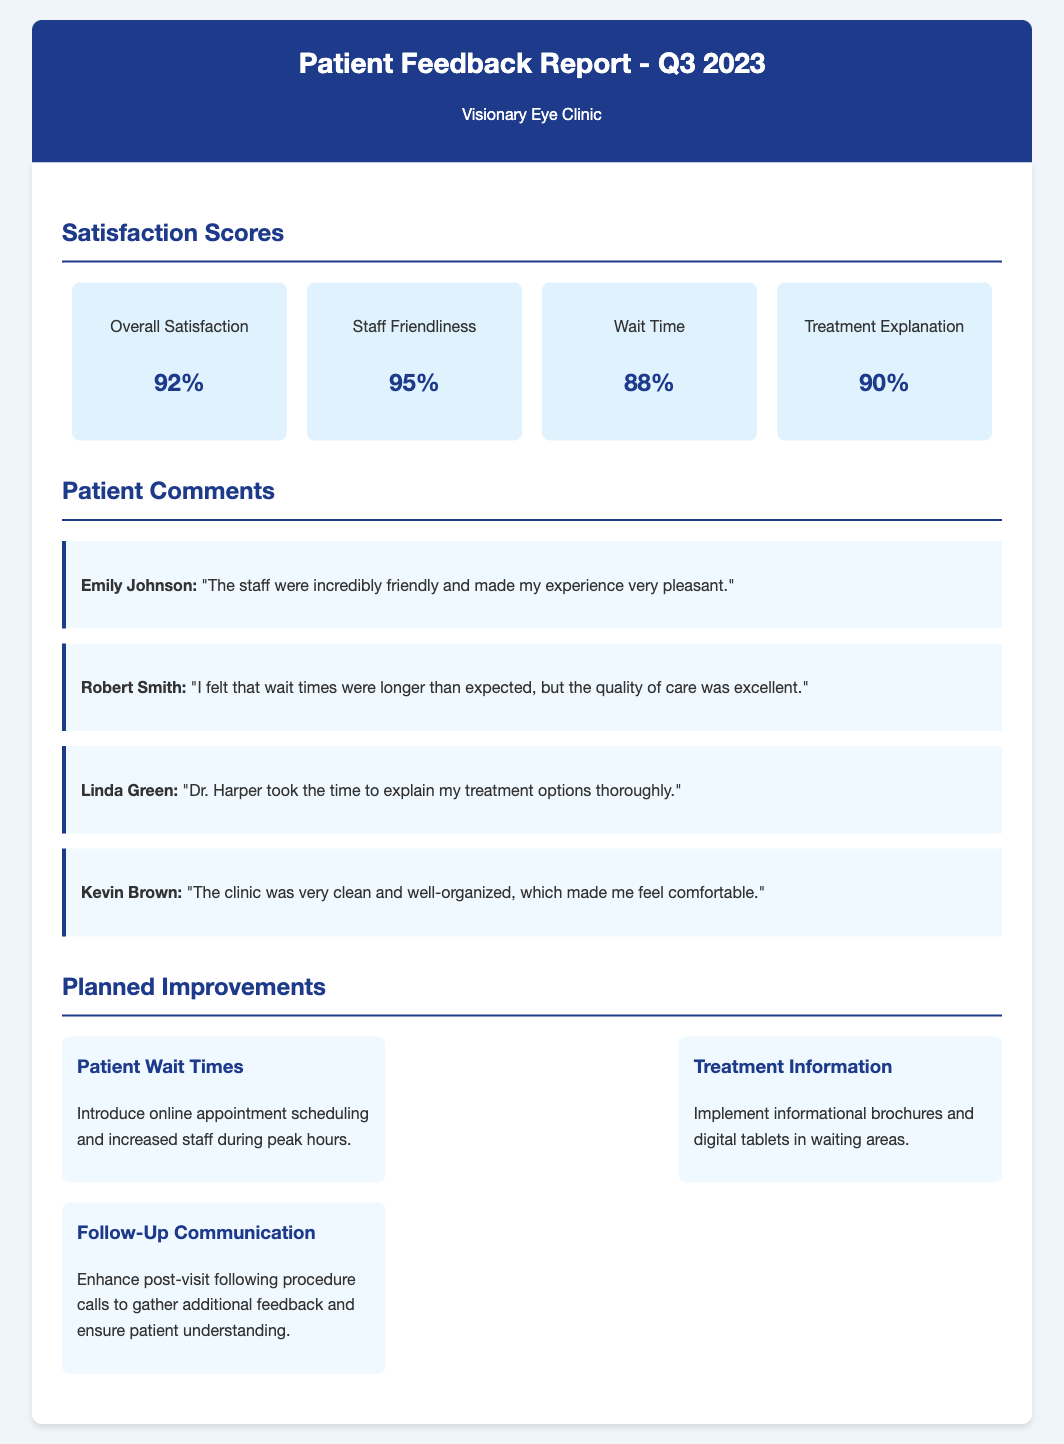What was the overall satisfaction score? The overall satisfaction score is specifically noted in the document under satisfaction scores.
Answer: 92% What percentage of patients rated staff friendliness? The percentage rating for staff friendliness is included as a satisfaction score in the document.
Answer: 95% Who praised the cleanliness and organization of the clinic? The comment mentioning cleanliness and organization is attributed to a specific patient in the comments section.
Answer: Kevin Brown What improvement is suggested for patient wait times? The improvement for patient wait times is detailed in the planned improvements section of the document.
Answer: Online appointment scheduling and increased staff during peak hours Which area received the lowest satisfaction score? By comparing all validated scores in the satisfaction section, the area with the lowest score can be identified.
Answer: Wait Time 